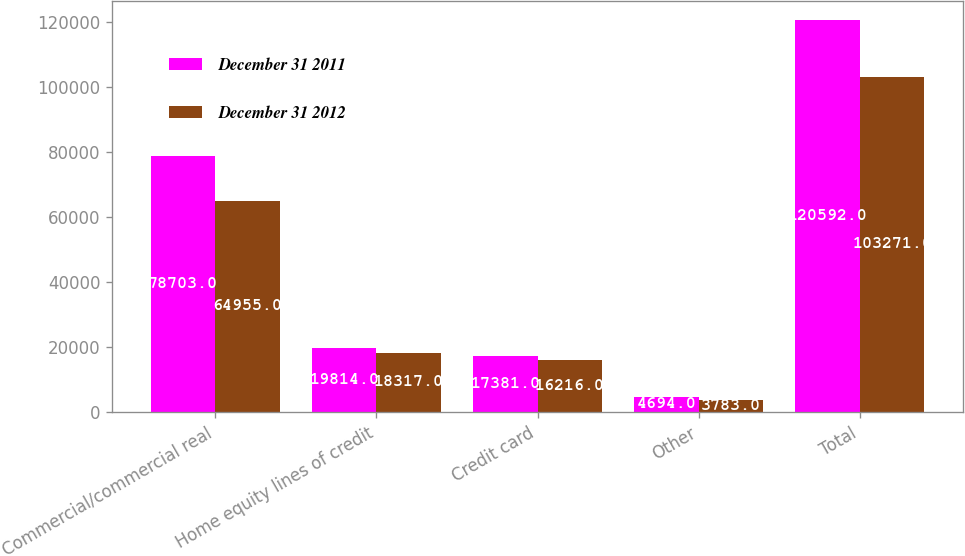Convert chart. <chart><loc_0><loc_0><loc_500><loc_500><stacked_bar_chart><ecel><fcel>Commercial/commercial real<fcel>Home equity lines of credit<fcel>Credit card<fcel>Other<fcel>Total<nl><fcel>December 31 2011<fcel>78703<fcel>19814<fcel>17381<fcel>4694<fcel>120592<nl><fcel>December 31 2012<fcel>64955<fcel>18317<fcel>16216<fcel>3783<fcel>103271<nl></chart> 